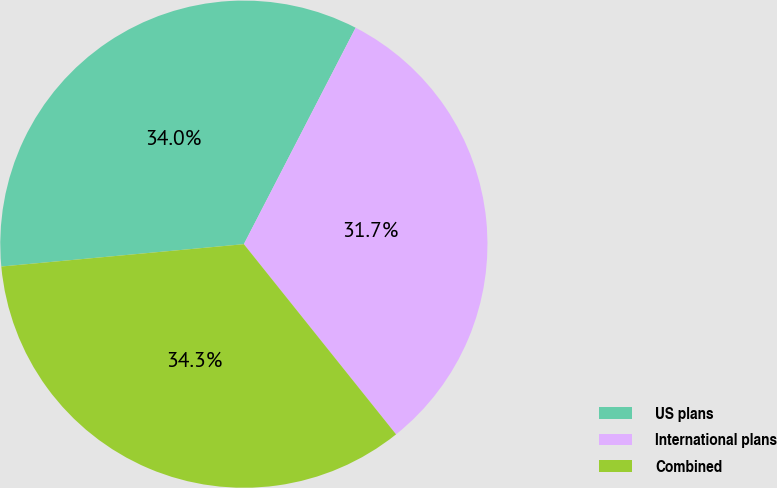Convert chart to OTSL. <chart><loc_0><loc_0><loc_500><loc_500><pie_chart><fcel>US plans<fcel>International plans<fcel>Combined<nl><fcel>34.05%<fcel>31.67%<fcel>34.28%<nl></chart> 